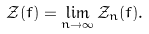<formula> <loc_0><loc_0><loc_500><loc_500>\mathcal { Z } ( f ) = \lim _ { n \rightarrow \infty } \mathcal { Z } _ { n } ( f ) .</formula> 